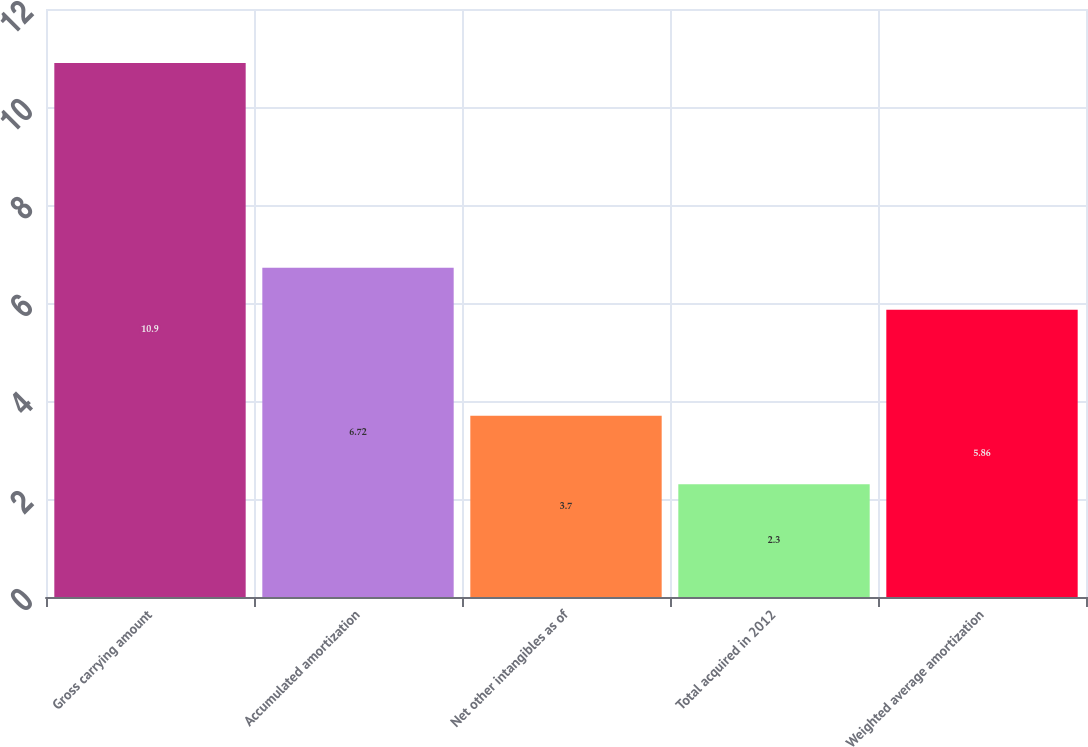Convert chart. <chart><loc_0><loc_0><loc_500><loc_500><bar_chart><fcel>Gross carrying amount<fcel>Accumulated amortization<fcel>Net other intangibles as of<fcel>Total acquired in 2012<fcel>Weighted average amortization<nl><fcel>10.9<fcel>6.72<fcel>3.7<fcel>2.3<fcel>5.86<nl></chart> 